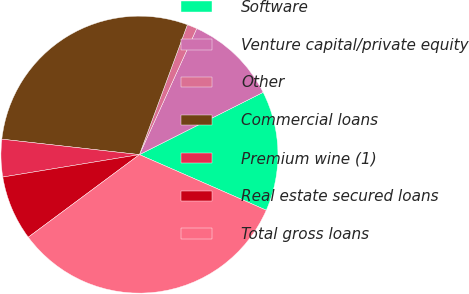Convert chart to OTSL. <chart><loc_0><loc_0><loc_500><loc_500><pie_chart><fcel>Software<fcel>Venture capital/private equity<fcel>Other<fcel>Commercial loans<fcel>Premium wine (1)<fcel>Real estate secured loans<fcel>Total gross loans<nl><fcel>14.0%<fcel>10.79%<fcel>1.16%<fcel>28.85%<fcel>4.37%<fcel>7.58%<fcel>33.26%<nl></chart> 